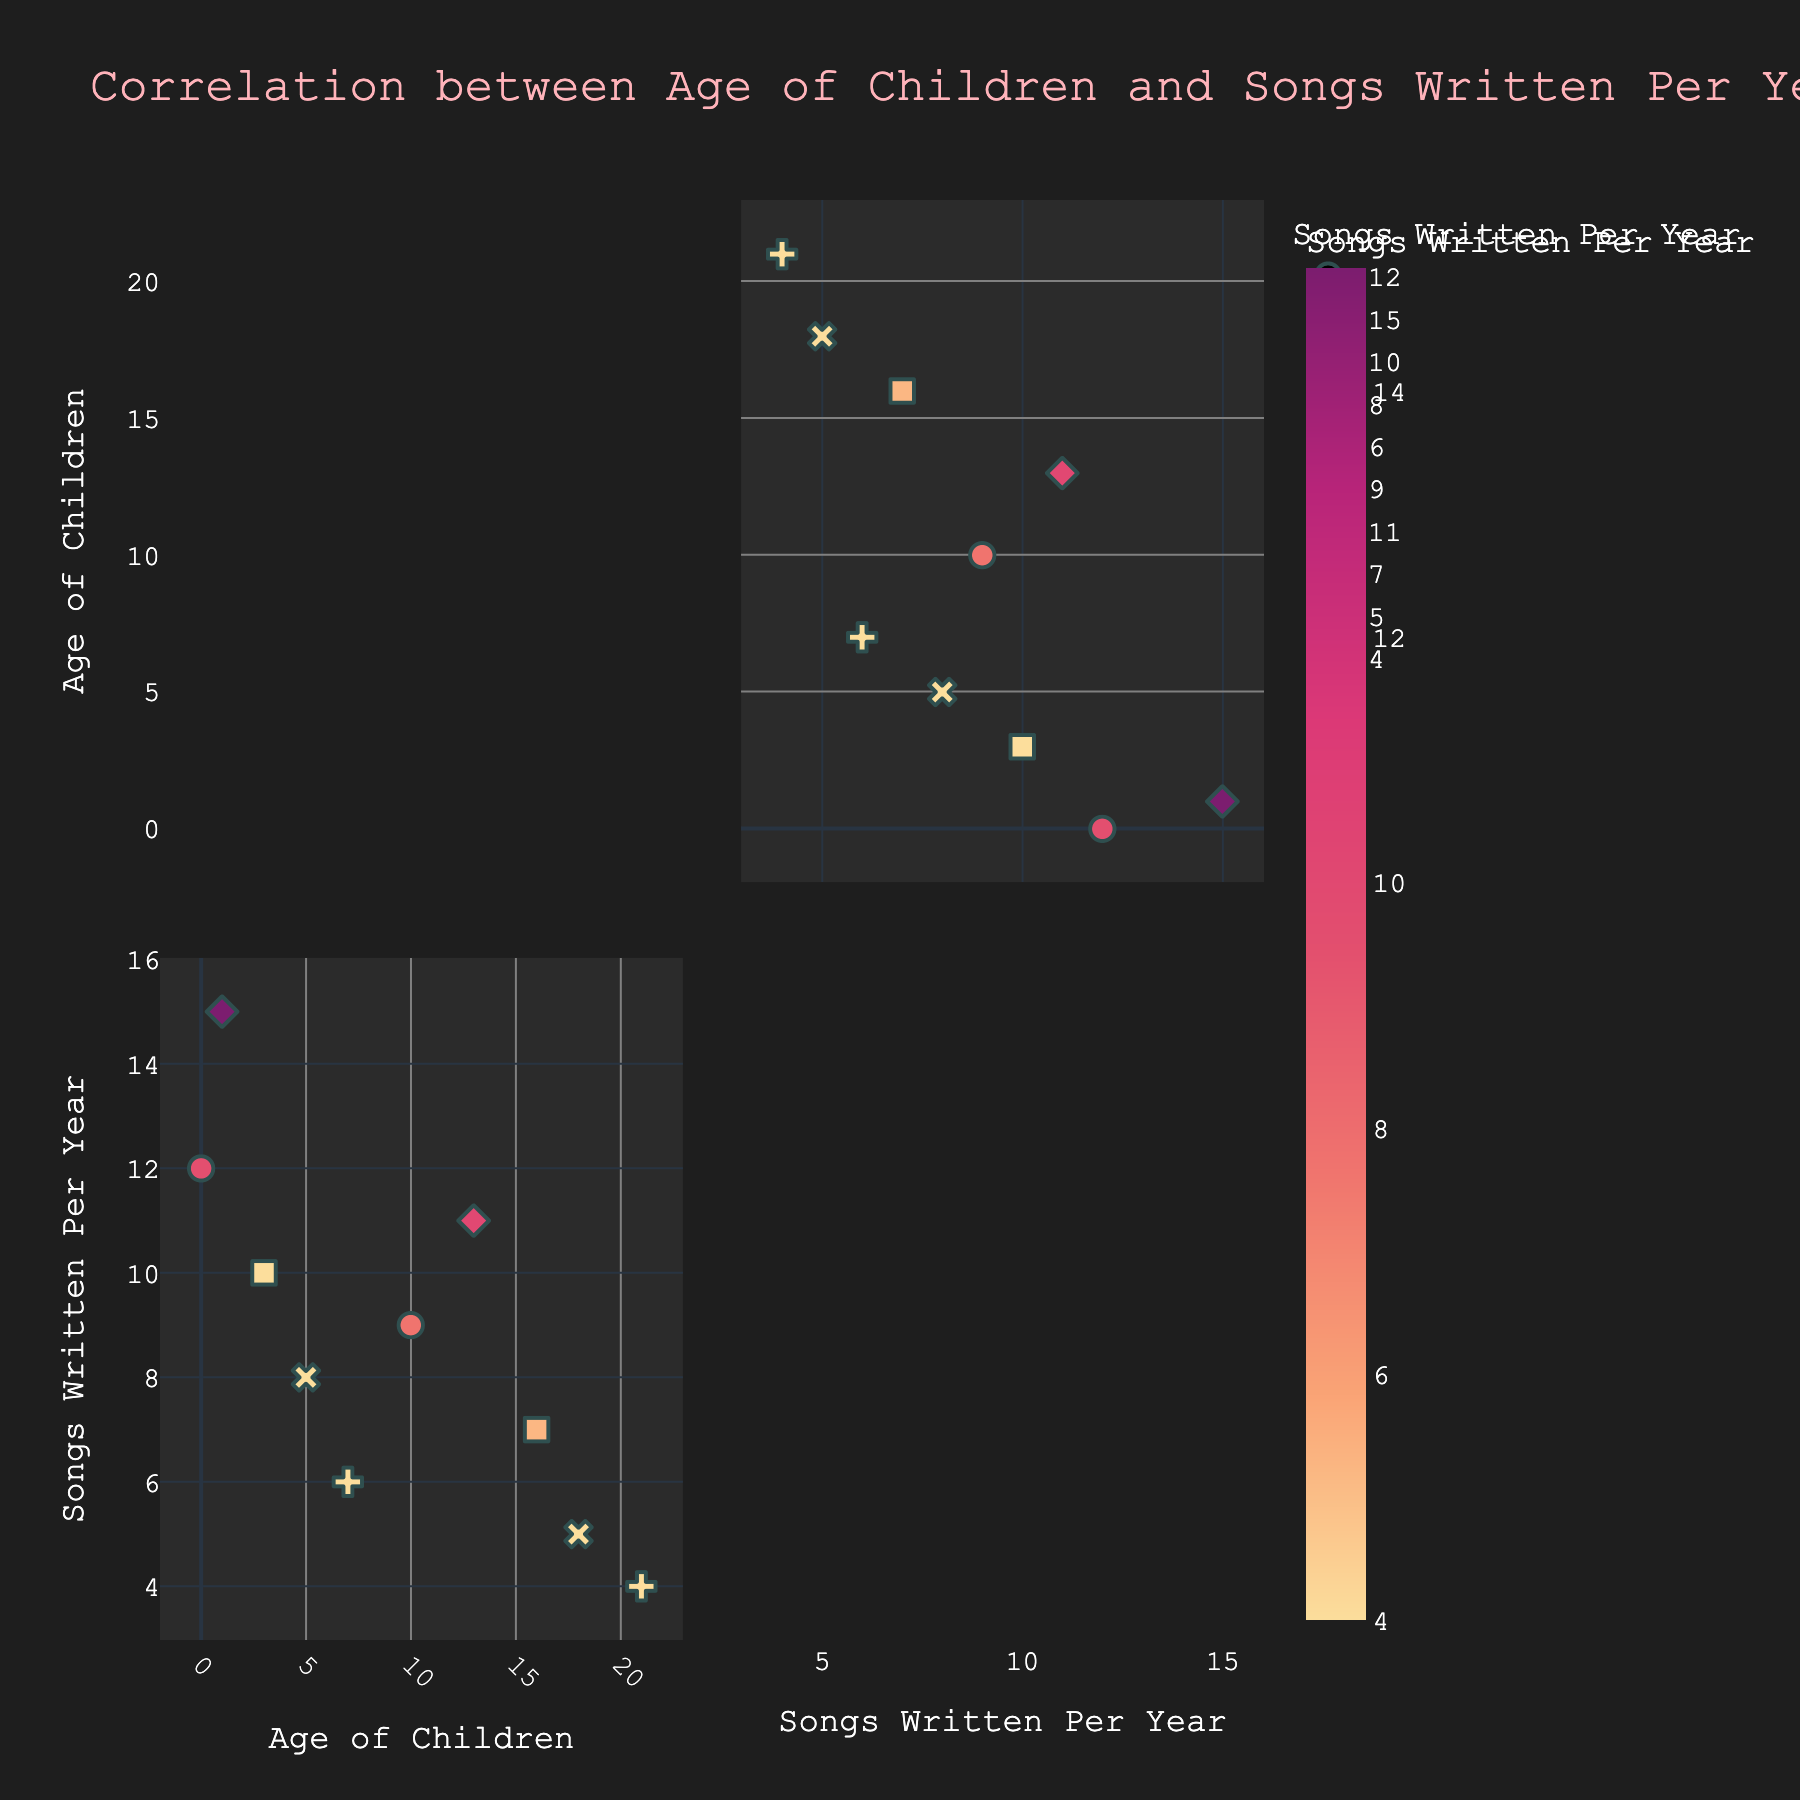What is the title of the scatterplot matrix? The title of the scatterplot matrix is provided at the top of the figure, which helps to understand what the data represents.
Answer: Correlation between Age of Children and Songs Written Per Year What are the axis labels in the scatterplot matrix? Axis labels define what each axis represents in the plot. The x-axis is labeled "Age of Children" and the y-axis is labeled "Songs Written Per Year."
Answer: Age of Children, Songs Written Per Year How many data points are represented in the scatterplot matrix? The scatterplot matrix includes data points that represent each age of children and the corresponding number of songs written per year. There are 10 data points corresponding to each row of the dataset provided.
Answer: 10 How does the number of songs written per year change as the children age from 0 to 21 years? To understand the trend, observe the scatter points from the left (age 0) to the right (age 21) in the matrix. The number of songs written per year appears to generally decrease as children age.
Answer: Decreases Which age group of children corresponds to the highest number of songs written per year? Identify the highest y-value that corresponds to the "Songs Written Per Year" axis and then check the x-value for "Age of Children." The highest number of songs written per year, 15, corresponds to the age of 1 year.
Answer: 1 year Compare the number of songs written per year when children are 0 years old and 21 years old. Locate the data points for ages 0 and 21 and compare their corresponding values on the y-axis. At age 0, 12 songs were written per year, while at age 21, 4 songs were written per year.
Answer: 12 vs. 4 What is the average number of songs written per year for children aged between 0 and 10 years? Calculate the average by summing up the number of songs written per year for children aged 0, 1, 3, 5, 7, and 10 years and then dividing by the number of ages. (12+15+10+8+6+9)/6 = 60/6.
Answer: 10 Is there any age of children where the number of songs written per year is the same? If so, what is that number and age? Check if there are any repeated y-values corresponding to different x-values in the matrix. The number of songs written per year (10) appears for both 3 and 13 years age groups.
Answer: 10 at age 3 and 13 years What's the difference in the number of songs written per year between children aged 3 years and children aged 16 years? Locate the y-values for ages 3 and 16, then find the difference between them. At age 3, the number of songs written per year is 10, and at age 16, it is 7. The difference is 10 - 7.
Answer: 3 Which age group of children corresponds to the lowest number of songs written per year? Identify the lowest y-value that corresponds to the "Songs Written Per Year" axis and then check the x-value for "Age of Children." The lowest number of songs written per year, 4, corresponds to the age of 21 years.
Answer: 21 years 